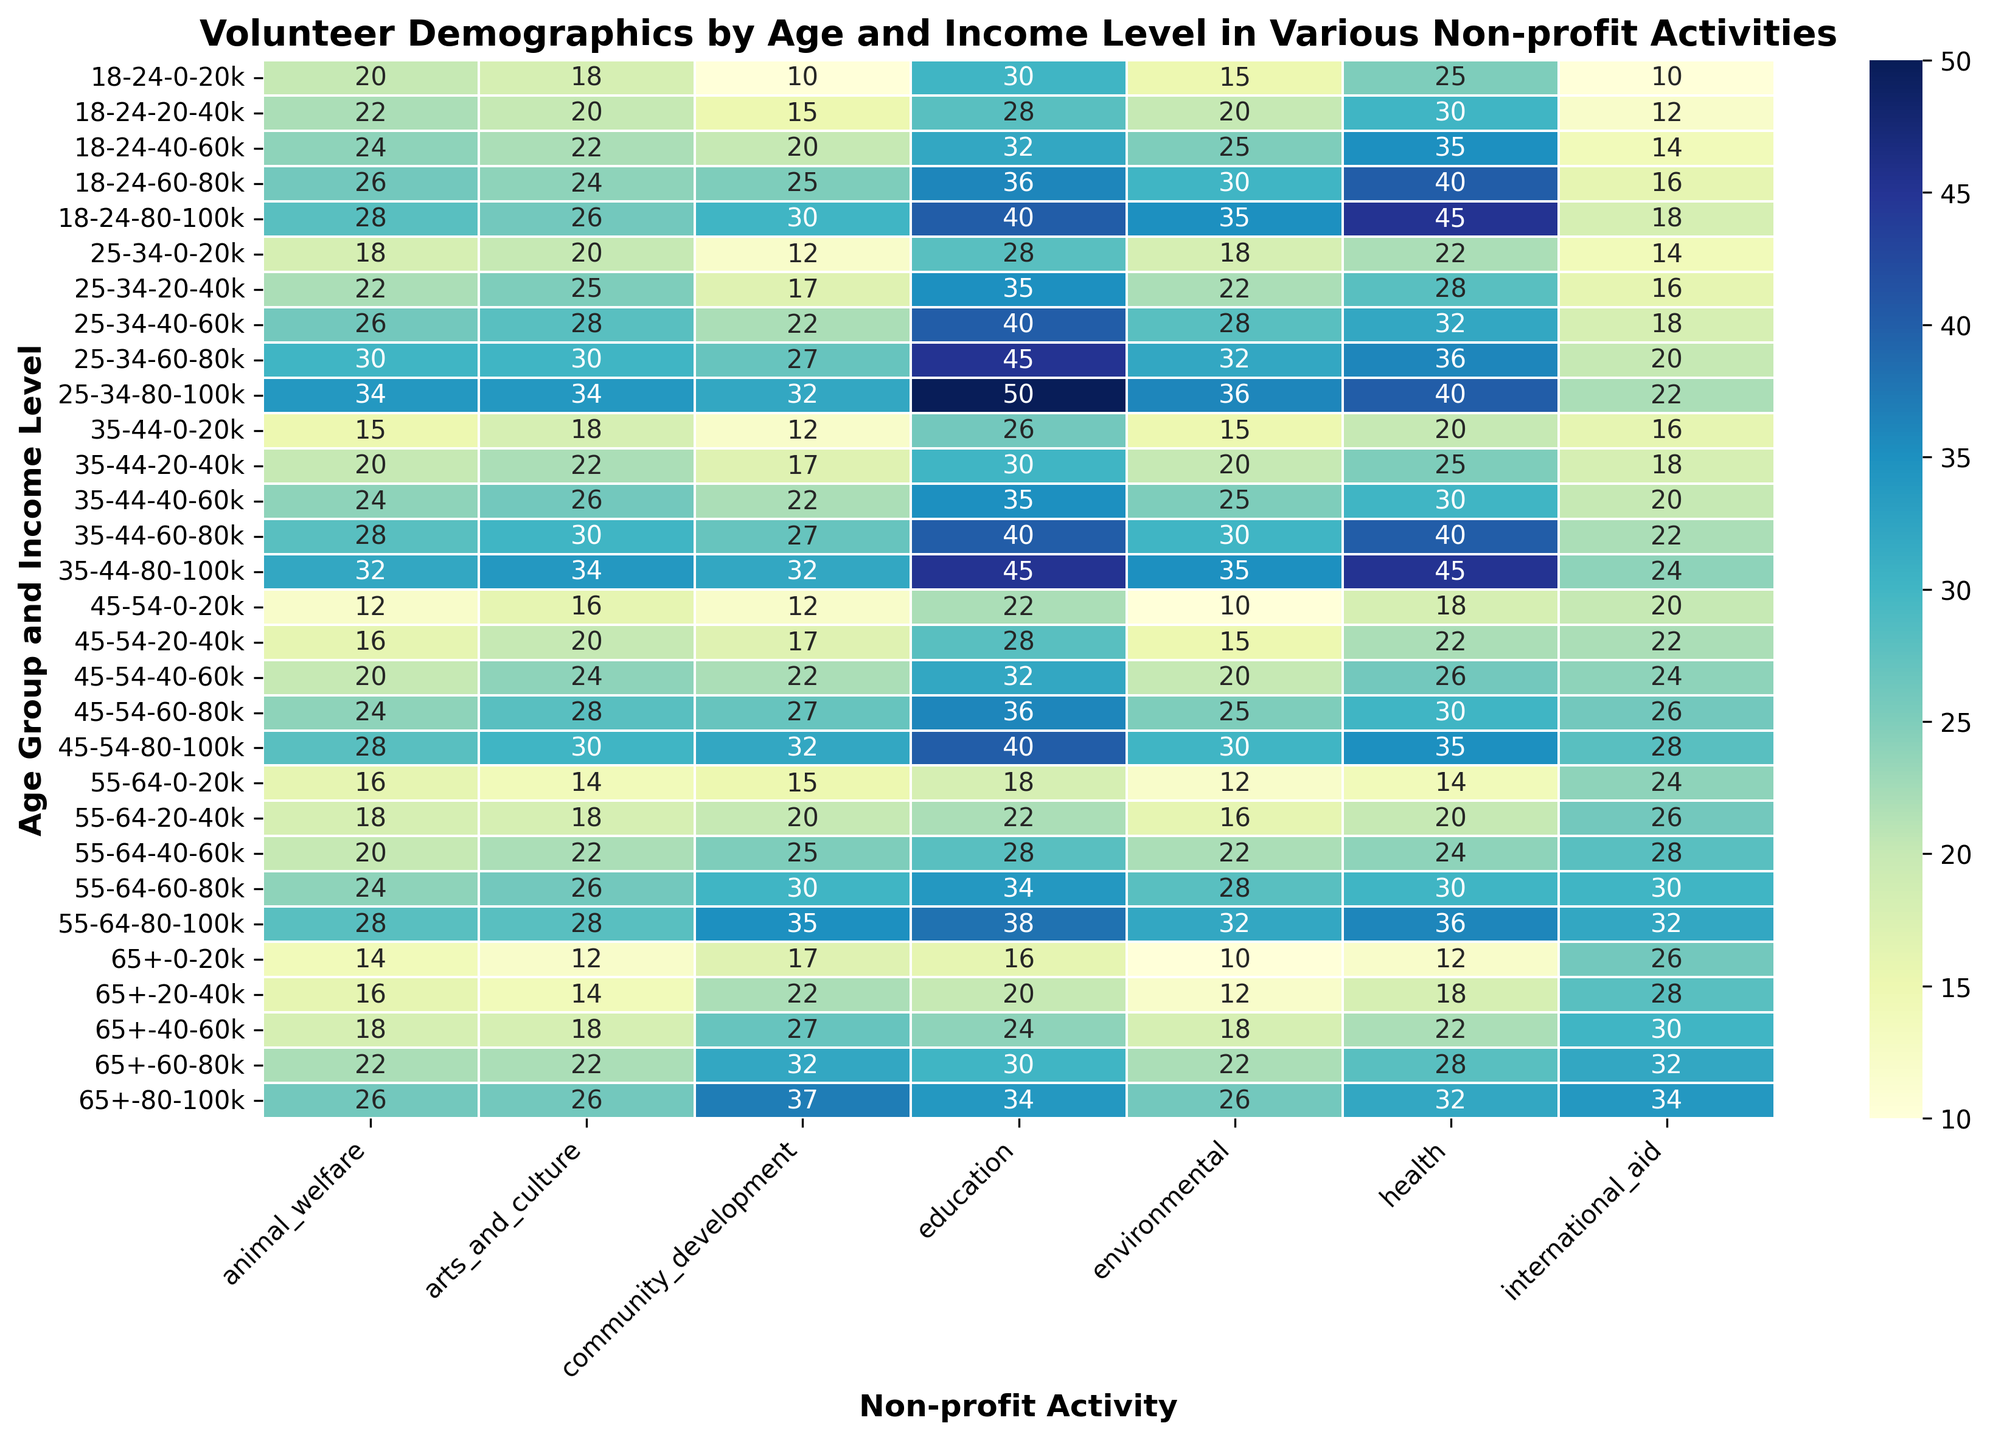What is the highest number of volunteers for the 18-24 age group across all activities and income levels? To determine this, we need to look at the volunteer numbers for the 18-24 age group in each activity and income level. The highest value is the maximum value shown in the heatmap for this age group.
Answer: 45 Which age group and income level has the highest participation in animal welfare activities? Find the darkest cell in the animal welfare column and then locate the age group and income level corresponding to that cell.
Answer: 65+, 80-100k Between the 25-34 and 35-44 age groups, which has more volunteers involved in community development activities in the 40-60k income level? Find the community development volunteer numbers for both age groups at the 40-60k income level and compare them. 25-34 age group has 22, and 35-44 age group has 22.
Answer: They are equal What is the difference in the number of education volunteers between the 18-24 and 65+ age groups for the 80-100k income level? Find the education volunteer numbers for both age groups at the 80-100k income level and subtract the 65+ number from the 18-24 number. 18-24 has 40, and 65+ has 34. 40 - 34 = 6.
Answer: 6 What age group has the least number of health volunteers in the 0-20k income level? Find the health volunteer numbers for each age group in the 0-20k income level and identify the minimum value.
Answer: 65+ What is the total number of volunteers across all activities for the 45-54 age group in the 60-80k income level? Sum the number of volunteers across all activities for the 45-54 age group in the 60-80k income level. 25 + 30 + 36 + 27 + 24 + 28 + 26 = 196.
Answer: 196 Which income level has the most volunteers for international aid activities in the 55-64 age group? Find the international aid volunteer numbers for the 55-64 age group and identify the maximum value and corresponding income level.
Answer: 80-100k Compare the participation in environmental activities between the 35-44 and 45-54 age groups at the 20-40k income level. Which age group has higher participation? Find the environmental volunteer numbers for both age groups at the 20-40k income level and compare them. 35-44 has 20, and 45-54 has 15.
Answer: 35-44 What is the average number of volunteers for the arts and culture activities for the 25-34 age group across all income levels? Sum the arts and culture volunteer numbers for the 25-34 age group across all income levels and divide by the number of income levels. (20 + 25 + 28 + 30 + 34) / 5 = 27.4.
Answer: 27.4 